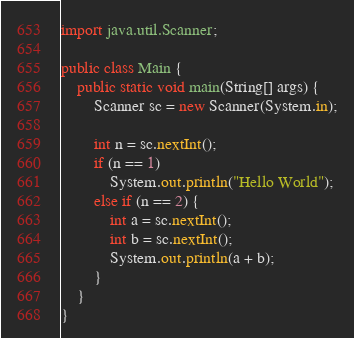<code> <loc_0><loc_0><loc_500><loc_500><_Java_>import java.util.Scanner;

public class Main {
    public static void main(String[] args) {
        Scanner sc = new Scanner(System.in);

        int n = sc.nextInt();
        if (n == 1)
            System.out.println("Hello World");
        else if (n == 2) {
            int a = sc.nextInt();
            int b = sc.nextInt();
            System.out.println(a + b);
        }
    }
}
</code> 